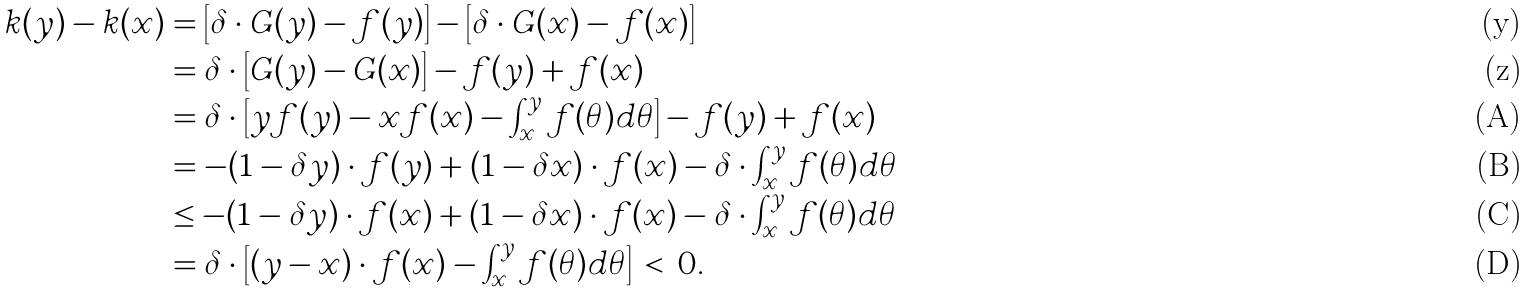<formula> <loc_0><loc_0><loc_500><loc_500>k ( y ) - k ( x ) & = \left [ \delta \cdot G ( y ) - f ( y ) \right ] - \left [ \delta \cdot G ( x ) - f ( x ) \right ] \\ & = \delta \cdot \left [ G ( y ) - G ( x ) \right ] - f ( y ) + f ( x ) \\ & = \delta \cdot \left [ y f ( y ) - x f ( x ) - \int _ { x } ^ { y } f ( \theta ) d \theta \right ] - f ( y ) + f ( x ) \\ & = - ( 1 - \delta y ) \cdot f ( y ) + ( 1 - \delta x ) \cdot f ( x ) - \delta \cdot \int _ { x } ^ { y } f ( \theta ) d \theta \\ & \leq - ( 1 - \delta y ) \cdot f ( x ) + ( 1 - \delta x ) \cdot f ( x ) - \delta \cdot \int _ { x } ^ { y } f ( \theta ) d \theta \\ & = \delta \cdot \left [ ( y - x ) \cdot f ( x ) - \int _ { x } ^ { y } f ( \theta ) d \theta \right ] \, < \, 0 .</formula> 